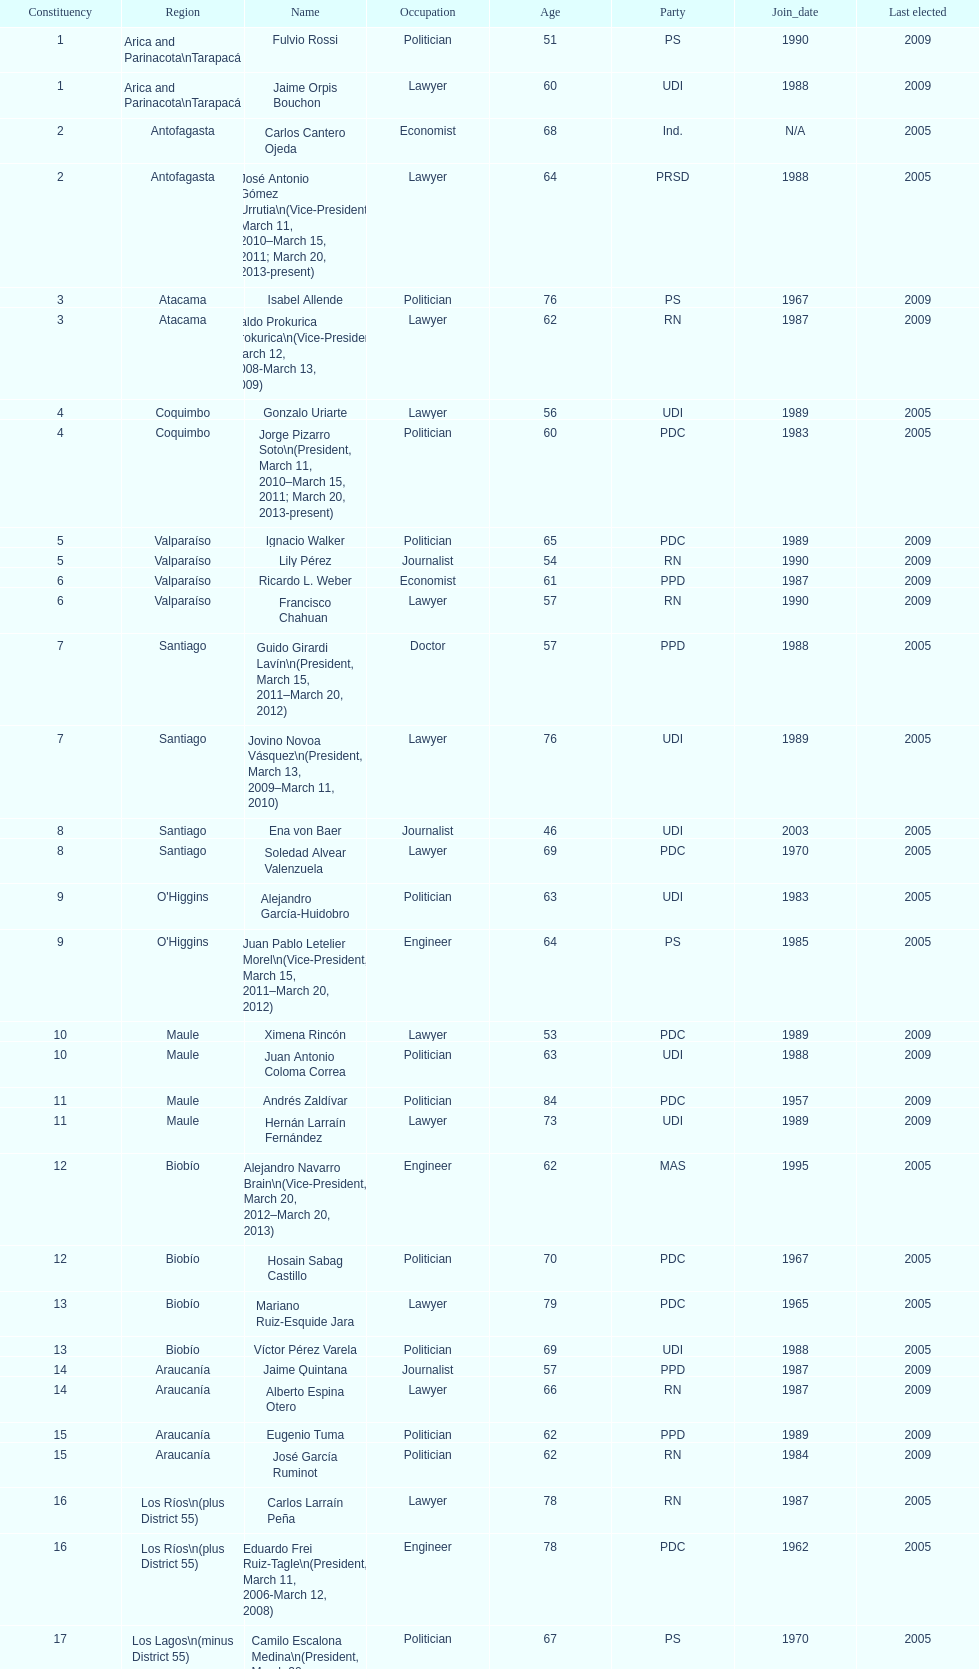Who was not last elected in either 2005 or 2009? Antonio Horvath Kiss. 